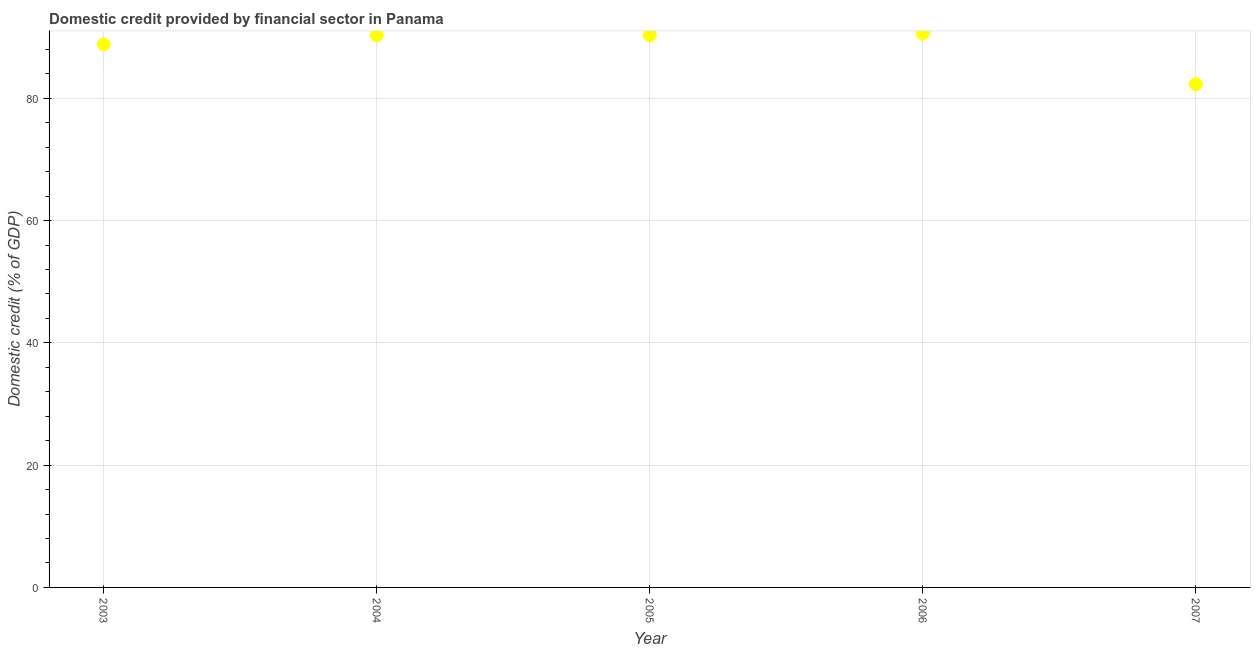What is the domestic credit provided by financial sector in 2007?
Offer a terse response. 82.31. Across all years, what is the maximum domestic credit provided by financial sector?
Your response must be concise. 90.62. Across all years, what is the minimum domestic credit provided by financial sector?
Your answer should be very brief. 82.31. In which year was the domestic credit provided by financial sector maximum?
Your response must be concise. 2006. In which year was the domestic credit provided by financial sector minimum?
Make the answer very short. 2007. What is the sum of the domestic credit provided by financial sector?
Provide a succinct answer. 442.4. What is the difference between the domestic credit provided by financial sector in 2003 and 2007?
Your answer should be compact. 6.51. What is the average domestic credit provided by financial sector per year?
Ensure brevity in your answer.  88.48. What is the median domestic credit provided by financial sector?
Offer a terse response. 90.32. Do a majority of the years between 2006 and 2007 (inclusive) have domestic credit provided by financial sector greater than 40 %?
Offer a very short reply. Yes. What is the ratio of the domestic credit provided by financial sector in 2005 to that in 2007?
Give a very brief answer. 1.1. Is the difference between the domestic credit provided by financial sector in 2003 and 2007 greater than the difference between any two years?
Ensure brevity in your answer.  No. What is the difference between the highest and the second highest domestic credit provided by financial sector?
Provide a succinct answer. 0.29. What is the difference between the highest and the lowest domestic credit provided by financial sector?
Provide a short and direct response. 8.31. Does the domestic credit provided by financial sector monotonically increase over the years?
Offer a terse response. No. How many dotlines are there?
Keep it short and to the point. 1. How many years are there in the graph?
Provide a succinct answer. 5. What is the difference between two consecutive major ticks on the Y-axis?
Make the answer very short. 20. Are the values on the major ticks of Y-axis written in scientific E-notation?
Provide a succinct answer. No. Does the graph contain any zero values?
Ensure brevity in your answer.  No. What is the title of the graph?
Offer a terse response. Domestic credit provided by financial sector in Panama. What is the label or title of the X-axis?
Offer a very short reply. Year. What is the label or title of the Y-axis?
Make the answer very short. Domestic credit (% of GDP). What is the Domestic credit (% of GDP) in 2003?
Your response must be concise. 88.82. What is the Domestic credit (% of GDP) in 2004?
Your response must be concise. 90.33. What is the Domestic credit (% of GDP) in 2005?
Your response must be concise. 90.32. What is the Domestic credit (% of GDP) in 2006?
Ensure brevity in your answer.  90.62. What is the Domestic credit (% of GDP) in 2007?
Your answer should be very brief. 82.31. What is the difference between the Domestic credit (% of GDP) in 2003 and 2004?
Offer a very short reply. -1.52. What is the difference between the Domestic credit (% of GDP) in 2003 and 2005?
Provide a short and direct response. -1.5. What is the difference between the Domestic credit (% of GDP) in 2003 and 2006?
Your response must be concise. -1.8. What is the difference between the Domestic credit (% of GDP) in 2003 and 2007?
Your answer should be compact. 6.51. What is the difference between the Domestic credit (% of GDP) in 2004 and 2005?
Keep it short and to the point. 0.01. What is the difference between the Domestic credit (% of GDP) in 2004 and 2006?
Keep it short and to the point. -0.29. What is the difference between the Domestic credit (% of GDP) in 2004 and 2007?
Offer a terse response. 8.02. What is the difference between the Domestic credit (% of GDP) in 2005 and 2006?
Your answer should be compact. -0.3. What is the difference between the Domestic credit (% of GDP) in 2005 and 2007?
Offer a terse response. 8.01. What is the difference between the Domestic credit (% of GDP) in 2006 and 2007?
Offer a very short reply. 8.31. What is the ratio of the Domestic credit (% of GDP) in 2003 to that in 2005?
Ensure brevity in your answer.  0.98. What is the ratio of the Domestic credit (% of GDP) in 2003 to that in 2006?
Your response must be concise. 0.98. What is the ratio of the Domestic credit (% of GDP) in 2003 to that in 2007?
Your response must be concise. 1.08. What is the ratio of the Domestic credit (% of GDP) in 2004 to that in 2005?
Keep it short and to the point. 1. What is the ratio of the Domestic credit (% of GDP) in 2004 to that in 2006?
Your answer should be compact. 1. What is the ratio of the Domestic credit (% of GDP) in 2004 to that in 2007?
Make the answer very short. 1.1. What is the ratio of the Domestic credit (% of GDP) in 2005 to that in 2007?
Your response must be concise. 1.1. What is the ratio of the Domestic credit (% of GDP) in 2006 to that in 2007?
Your answer should be very brief. 1.1. 